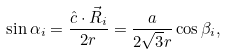<formula> <loc_0><loc_0><loc_500><loc_500>\sin \alpha _ { i } = \frac { \hat { c } \cdot \vec { R } _ { i } } { 2 r } = \frac { a } { 2 \sqrt { 3 } r } \cos \beta _ { i } ,</formula> 